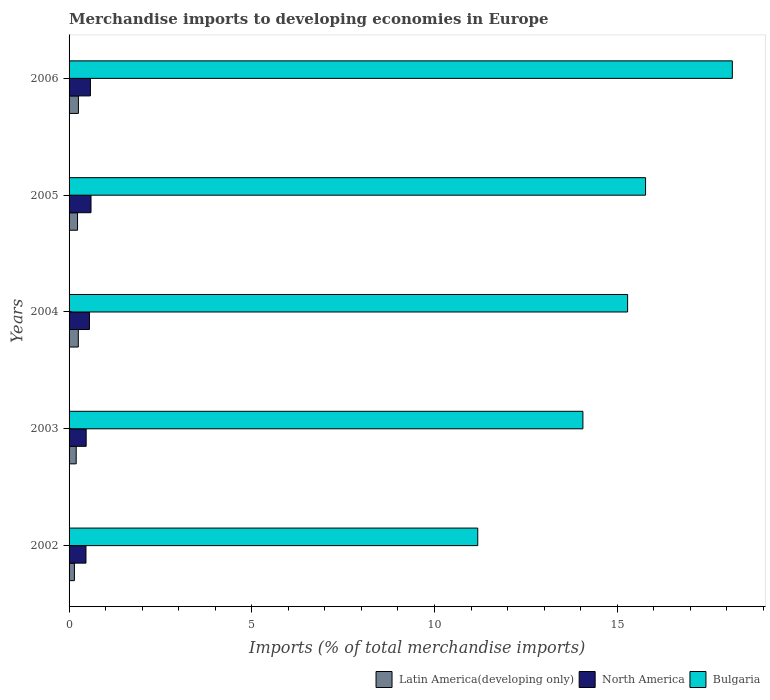How many different coloured bars are there?
Keep it short and to the point. 3. Are the number of bars per tick equal to the number of legend labels?
Give a very brief answer. Yes. Are the number of bars on each tick of the Y-axis equal?
Your answer should be compact. Yes. How many bars are there on the 2nd tick from the bottom?
Give a very brief answer. 3. What is the label of the 1st group of bars from the top?
Your response must be concise. 2006. In how many cases, is the number of bars for a given year not equal to the number of legend labels?
Keep it short and to the point. 0. What is the percentage total merchandise imports in North America in 2004?
Make the answer very short. 0.56. Across all years, what is the maximum percentage total merchandise imports in Latin America(developing only)?
Offer a very short reply. 0.26. Across all years, what is the minimum percentage total merchandise imports in North America?
Offer a terse response. 0.46. In which year was the percentage total merchandise imports in Bulgaria minimum?
Provide a succinct answer. 2002. What is the total percentage total merchandise imports in Latin America(developing only) in the graph?
Keep it short and to the point. 1.08. What is the difference between the percentage total merchandise imports in Latin America(developing only) in 2003 and that in 2006?
Offer a very short reply. -0.06. What is the difference between the percentage total merchandise imports in Bulgaria in 2005 and the percentage total merchandise imports in North America in 2003?
Make the answer very short. 15.31. What is the average percentage total merchandise imports in North America per year?
Offer a very short reply. 0.53. In the year 2003, what is the difference between the percentage total merchandise imports in Bulgaria and percentage total merchandise imports in Latin America(developing only)?
Ensure brevity in your answer.  13.87. In how many years, is the percentage total merchandise imports in North America greater than 10 %?
Your response must be concise. 0. What is the ratio of the percentage total merchandise imports in Bulgaria in 2005 to that in 2006?
Your answer should be compact. 0.87. What is the difference between the highest and the second highest percentage total merchandise imports in North America?
Provide a short and direct response. 0.02. What is the difference between the highest and the lowest percentage total merchandise imports in Bulgaria?
Make the answer very short. 6.97. How many bars are there?
Offer a very short reply. 15. Are all the bars in the graph horizontal?
Make the answer very short. Yes. Does the graph contain grids?
Offer a very short reply. No. Where does the legend appear in the graph?
Make the answer very short. Bottom right. What is the title of the graph?
Keep it short and to the point. Merchandise imports to developing economies in Europe. Does "North America" appear as one of the legend labels in the graph?
Offer a very short reply. Yes. What is the label or title of the X-axis?
Your answer should be very brief. Imports (% of total merchandise imports). What is the label or title of the Y-axis?
Make the answer very short. Years. What is the Imports (% of total merchandise imports) in Latin America(developing only) in 2002?
Ensure brevity in your answer.  0.15. What is the Imports (% of total merchandise imports) of North America in 2002?
Give a very brief answer. 0.46. What is the Imports (% of total merchandise imports) of Bulgaria in 2002?
Your response must be concise. 11.18. What is the Imports (% of total merchandise imports) in Latin America(developing only) in 2003?
Make the answer very short. 0.2. What is the Imports (% of total merchandise imports) of North America in 2003?
Your answer should be compact. 0.47. What is the Imports (% of total merchandise imports) in Bulgaria in 2003?
Your answer should be compact. 14.06. What is the Imports (% of total merchandise imports) in Latin America(developing only) in 2004?
Offer a very short reply. 0.25. What is the Imports (% of total merchandise imports) in North America in 2004?
Keep it short and to the point. 0.56. What is the Imports (% of total merchandise imports) in Bulgaria in 2004?
Provide a short and direct response. 15.29. What is the Imports (% of total merchandise imports) in Latin America(developing only) in 2005?
Give a very brief answer. 0.23. What is the Imports (% of total merchandise imports) of North America in 2005?
Provide a succinct answer. 0.6. What is the Imports (% of total merchandise imports) of Bulgaria in 2005?
Keep it short and to the point. 15.78. What is the Imports (% of total merchandise imports) of Latin America(developing only) in 2006?
Offer a very short reply. 0.26. What is the Imports (% of total merchandise imports) in North America in 2006?
Provide a succinct answer. 0.58. What is the Imports (% of total merchandise imports) of Bulgaria in 2006?
Ensure brevity in your answer.  18.15. Across all years, what is the maximum Imports (% of total merchandise imports) of Latin America(developing only)?
Offer a terse response. 0.26. Across all years, what is the maximum Imports (% of total merchandise imports) of North America?
Your answer should be compact. 0.6. Across all years, what is the maximum Imports (% of total merchandise imports) of Bulgaria?
Ensure brevity in your answer.  18.15. Across all years, what is the minimum Imports (% of total merchandise imports) in Latin America(developing only)?
Your answer should be compact. 0.15. Across all years, what is the minimum Imports (% of total merchandise imports) of North America?
Your answer should be compact. 0.46. Across all years, what is the minimum Imports (% of total merchandise imports) in Bulgaria?
Make the answer very short. 11.18. What is the total Imports (% of total merchandise imports) in Latin America(developing only) in the graph?
Offer a very short reply. 1.08. What is the total Imports (% of total merchandise imports) in North America in the graph?
Make the answer very short. 2.67. What is the total Imports (% of total merchandise imports) of Bulgaria in the graph?
Offer a very short reply. 74.46. What is the difference between the Imports (% of total merchandise imports) in Latin America(developing only) in 2002 and that in 2003?
Give a very brief answer. -0.05. What is the difference between the Imports (% of total merchandise imports) in North America in 2002 and that in 2003?
Your answer should be compact. -0.01. What is the difference between the Imports (% of total merchandise imports) of Bulgaria in 2002 and that in 2003?
Provide a succinct answer. -2.88. What is the difference between the Imports (% of total merchandise imports) of Latin America(developing only) in 2002 and that in 2004?
Your answer should be compact. -0.11. What is the difference between the Imports (% of total merchandise imports) in North America in 2002 and that in 2004?
Your answer should be compact. -0.1. What is the difference between the Imports (% of total merchandise imports) of Bulgaria in 2002 and that in 2004?
Your response must be concise. -4.1. What is the difference between the Imports (% of total merchandise imports) of Latin America(developing only) in 2002 and that in 2005?
Provide a succinct answer. -0.09. What is the difference between the Imports (% of total merchandise imports) in North America in 2002 and that in 2005?
Offer a very short reply. -0.14. What is the difference between the Imports (% of total merchandise imports) of Bulgaria in 2002 and that in 2005?
Your answer should be very brief. -4.59. What is the difference between the Imports (% of total merchandise imports) of Latin America(developing only) in 2002 and that in 2006?
Keep it short and to the point. -0.11. What is the difference between the Imports (% of total merchandise imports) in North America in 2002 and that in 2006?
Give a very brief answer. -0.12. What is the difference between the Imports (% of total merchandise imports) of Bulgaria in 2002 and that in 2006?
Your answer should be very brief. -6.97. What is the difference between the Imports (% of total merchandise imports) in Latin America(developing only) in 2003 and that in 2004?
Offer a terse response. -0.06. What is the difference between the Imports (% of total merchandise imports) in North America in 2003 and that in 2004?
Your answer should be very brief. -0.09. What is the difference between the Imports (% of total merchandise imports) in Bulgaria in 2003 and that in 2004?
Make the answer very short. -1.22. What is the difference between the Imports (% of total merchandise imports) in Latin America(developing only) in 2003 and that in 2005?
Offer a terse response. -0.04. What is the difference between the Imports (% of total merchandise imports) of North America in 2003 and that in 2005?
Keep it short and to the point. -0.13. What is the difference between the Imports (% of total merchandise imports) of Bulgaria in 2003 and that in 2005?
Give a very brief answer. -1.71. What is the difference between the Imports (% of total merchandise imports) in Latin America(developing only) in 2003 and that in 2006?
Your answer should be very brief. -0.06. What is the difference between the Imports (% of total merchandise imports) of North America in 2003 and that in 2006?
Your answer should be very brief. -0.12. What is the difference between the Imports (% of total merchandise imports) in Bulgaria in 2003 and that in 2006?
Provide a short and direct response. -4.09. What is the difference between the Imports (% of total merchandise imports) of Latin America(developing only) in 2004 and that in 2005?
Ensure brevity in your answer.  0.02. What is the difference between the Imports (% of total merchandise imports) in North America in 2004 and that in 2005?
Provide a short and direct response. -0.04. What is the difference between the Imports (% of total merchandise imports) of Bulgaria in 2004 and that in 2005?
Your answer should be compact. -0.49. What is the difference between the Imports (% of total merchandise imports) in Latin America(developing only) in 2004 and that in 2006?
Your answer should be compact. -0. What is the difference between the Imports (% of total merchandise imports) in North America in 2004 and that in 2006?
Provide a succinct answer. -0.03. What is the difference between the Imports (% of total merchandise imports) of Bulgaria in 2004 and that in 2006?
Give a very brief answer. -2.87. What is the difference between the Imports (% of total merchandise imports) in Latin America(developing only) in 2005 and that in 2006?
Your answer should be very brief. -0.02. What is the difference between the Imports (% of total merchandise imports) of North America in 2005 and that in 2006?
Provide a short and direct response. 0.02. What is the difference between the Imports (% of total merchandise imports) in Bulgaria in 2005 and that in 2006?
Your answer should be compact. -2.37. What is the difference between the Imports (% of total merchandise imports) in Latin America(developing only) in 2002 and the Imports (% of total merchandise imports) in North America in 2003?
Provide a succinct answer. -0.32. What is the difference between the Imports (% of total merchandise imports) of Latin America(developing only) in 2002 and the Imports (% of total merchandise imports) of Bulgaria in 2003?
Make the answer very short. -13.92. What is the difference between the Imports (% of total merchandise imports) of Latin America(developing only) in 2002 and the Imports (% of total merchandise imports) of North America in 2004?
Provide a succinct answer. -0.41. What is the difference between the Imports (% of total merchandise imports) in Latin America(developing only) in 2002 and the Imports (% of total merchandise imports) in Bulgaria in 2004?
Offer a terse response. -15.14. What is the difference between the Imports (% of total merchandise imports) of North America in 2002 and the Imports (% of total merchandise imports) of Bulgaria in 2004?
Give a very brief answer. -14.82. What is the difference between the Imports (% of total merchandise imports) of Latin America(developing only) in 2002 and the Imports (% of total merchandise imports) of North America in 2005?
Give a very brief answer. -0.45. What is the difference between the Imports (% of total merchandise imports) of Latin America(developing only) in 2002 and the Imports (% of total merchandise imports) of Bulgaria in 2005?
Ensure brevity in your answer.  -15.63. What is the difference between the Imports (% of total merchandise imports) in North America in 2002 and the Imports (% of total merchandise imports) in Bulgaria in 2005?
Provide a short and direct response. -15.31. What is the difference between the Imports (% of total merchandise imports) of Latin America(developing only) in 2002 and the Imports (% of total merchandise imports) of North America in 2006?
Offer a very short reply. -0.44. What is the difference between the Imports (% of total merchandise imports) in Latin America(developing only) in 2002 and the Imports (% of total merchandise imports) in Bulgaria in 2006?
Keep it short and to the point. -18.01. What is the difference between the Imports (% of total merchandise imports) in North America in 2002 and the Imports (% of total merchandise imports) in Bulgaria in 2006?
Provide a short and direct response. -17.69. What is the difference between the Imports (% of total merchandise imports) in Latin America(developing only) in 2003 and the Imports (% of total merchandise imports) in North America in 2004?
Offer a terse response. -0.36. What is the difference between the Imports (% of total merchandise imports) of Latin America(developing only) in 2003 and the Imports (% of total merchandise imports) of Bulgaria in 2004?
Provide a short and direct response. -15.09. What is the difference between the Imports (% of total merchandise imports) of North America in 2003 and the Imports (% of total merchandise imports) of Bulgaria in 2004?
Offer a terse response. -14.82. What is the difference between the Imports (% of total merchandise imports) of Latin America(developing only) in 2003 and the Imports (% of total merchandise imports) of North America in 2005?
Offer a terse response. -0.41. What is the difference between the Imports (% of total merchandise imports) in Latin America(developing only) in 2003 and the Imports (% of total merchandise imports) in Bulgaria in 2005?
Provide a succinct answer. -15.58. What is the difference between the Imports (% of total merchandise imports) in North America in 2003 and the Imports (% of total merchandise imports) in Bulgaria in 2005?
Your answer should be very brief. -15.31. What is the difference between the Imports (% of total merchandise imports) in Latin America(developing only) in 2003 and the Imports (% of total merchandise imports) in North America in 2006?
Offer a terse response. -0.39. What is the difference between the Imports (% of total merchandise imports) in Latin America(developing only) in 2003 and the Imports (% of total merchandise imports) in Bulgaria in 2006?
Give a very brief answer. -17.96. What is the difference between the Imports (% of total merchandise imports) in North America in 2003 and the Imports (% of total merchandise imports) in Bulgaria in 2006?
Your response must be concise. -17.68. What is the difference between the Imports (% of total merchandise imports) of Latin America(developing only) in 2004 and the Imports (% of total merchandise imports) of North America in 2005?
Your response must be concise. -0.35. What is the difference between the Imports (% of total merchandise imports) of Latin America(developing only) in 2004 and the Imports (% of total merchandise imports) of Bulgaria in 2005?
Keep it short and to the point. -15.52. What is the difference between the Imports (% of total merchandise imports) of North America in 2004 and the Imports (% of total merchandise imports) of Bulgaria in 2005?
Keep it short and to the point. -15.22. What is the difference between the Imports (% of total merchandise imports) in Latin America(developing only) in 2004 and the Imports (% of total merchandise imports) in North America in 2006?
Make the answer very short. -0.33. What is the difference between the Imports (% of total merchandise imports) of Latin America(developing only) in 2004 and the Imports (% of total merchandise imports) of Bulgaria in 2006?
Offer a terse response. -17.9. What is the difference between the Imports (% of total merchandise imports) in North America in 2004 and the Imports (% of total merchandise imports) in Bulgaria in 2006?
Provide a succinct answer. -17.59. What is the difference between the Imports (% of total merchandise imports) of Latin America(developing only) in 2005 and the Imports (% of total merchandise imports) of North America in 2006?
Your answer should be very brief. -0.35. What is the difference between the Imports (% of total merchandise imports) of Latin America(developing only) in 2005 and the Imports (% of total merchandise imports) of Bulgaria in 2006?
Make the answer very short. -17.92. What is the difference between the Imports (% of total merchandise imports) in North America in 2005 and the Imports (% of total merchandise imports) in Bulgaria in 2006?
Provide a short and direct response. -17.55. What is the average Imports (% of total merchandise imports) in Latin America(developing only) per year?
Provide a short and direct response. 0.22. What is the average Imports (% of total merchandise imports) in North America per year?
Offer a very short reply. 0.53. What is the average Imports (% of total merchandise imports) of Bulgaria per year?
Give a very brief answer. 14.89. In the year 2002, what is the difference between the Imports (% of total merchandise imports) in Latin America(developing only) and Imports (% of total merchandise imports) in North America?
Offer a terse response. -0.32. In the year 2002, what is the difference between the Imports (% of total merchandise imports) in Latin America(developing only) and Imports (% of total merchandise imports) in Bulgaria?
Make the answer very short. -11.04. In the year 2002, what is the difference between the Imports (% of total merchandise imports) in North America and Imports (% of total merchandise imports) in Bulgaria?
Give a very brief answer. -10.72. In the year 2003, what is the difference between the Imports (% of total merchandise imports) in Latin America(developing only) and Imports (% of total merchandise imports) in North America?
Provide a succinct answer. -0.27. In the year 2003, what is the difference between the Imports (% of total merchandise imports) in Latin America(developing only) and Imports (% of total merchandise imports) in Bulgaria?
Make the answer very short. -13.87. In the year 2003, what is the difference between the Imports (% of total merchandise imports) of North America and Imports (% of total merchandise imports) of Bulgaria?
Provide a succinct answer. -13.59. In the year 2004, what is the difference between the Imports (% of total merchandise imports) in Latin America(developing only) and Imports (% of total merchandise imports) in North America?
Ensure brevity in your answer.  -0.3. In the year 2004, what is the difference between the Imports (% of total merchandise imports) of Latin America(developing only) and Imports (% of total merchandise imports) of Bulgaria?
Make the answer very short. -15.03. In the year 2004, what is the difference between the Imports (% of total merchandise imports) in North America and Imports (% of total merchandise imports) in Bulgaria?
Your answer should be very brief. -14.73. In the year 2005, what is the difference between the Imports (% of total merchandise imports) of Latin America(developing only) and Imports (% of total merchandise imports) of North America?
Your answer should be very brief. -0.37. In the year 2005, what is the difference between the Imports (% of total merchandise imports) in Latin America(developing only) and Imports (% of total merchandise imports) in Bulgaria?
Your answer should be very brief. -15.55. In the year 2005, what is the difference between the Imports (% of total merchandise imports) in North America and Imports (% of total merchandise imports) in Bulgaria?
Keep it short and to the point. -15.18. In the year 2006, what is the difference between the Imports (% of total merchandise imports) in Latin America(developing only) and Imports (% of total merchandise imports) in North America?
Ensure brevity in your answer.  -0.33. In the year 2006, what is the difference between the Imports (% of total merchandise imports) in Latin America(developing only) and Imports (% of total merchandise imports) in Bulgaria?
Keep it short and to the point. -17.9. In the year 2006, what is the difference between the Imports (% of total merchandise imports) of North America and Imports (% of total merchandise imports) of Bulgaria?
Provide a succinct answer. -17.57. What is the ratio of the Imports (% of total merchandise imports) of Latin America(developing only) in 2002 to that in 2003?
Offer a terse response. 0.75. What is the ratio of the Imports (% of total merchandise imports) in North America in 2002 to that in 2003?
Offer a terse response. 0.99. What is the ratio of the Imports (% of total merchandise imports) in Bulgaria in 2002 to that in 2003?
Offer a terse response. 0.8. What is the ratio of the Imports (% of total merchandise imports) in Latin America(developing only) in 2002 to that in 2004?
Keep it short and to the point. 0.58. What is the ratio of the Imports (% of total merchandise imports) of North America in 2002 to that in 2004?
Your response must be concise. 0.83. What is the ratio of the Imports (% of total merchandise imports) of Bulgaria in 2002 to that in 2004?
Your response must be concise. 0.73. What is the ratio of the Imports (% of total merchandise imports) of Latin America(developing only) in 2002 to that in 2005?
Your answer should be very brief. 0.63. What is the ratio of the Imports (% of total merchandise imports) of North America in 2002 to that in 2005?
Make the answer very short. 0.77. What is the ratio of the Imports (% of total merchandise imports) of Bulgaria in 2002 to that in 2005?
Your response must be concise. 0.71. What is the ratio of the Imports (% of total merchandise imports) in Latin America(developing only) in 2002 to that in 2006?
Give a very brief answer. 0.57. What is the ratio of the Imports (% of total merchandise imports) of North America in 2002 to that in 2006?
Provide a short and direct response. 0.79. What is the ratio of the Imports (% of total merchandise imports) in Bulgaria in 2002 to that in 2006?
Offer a terse response. 0.62. What is the ratio of the Imports (% of total merchandise imports) of Latin America(developing only) in 2003 to that in 2004?
Your answer should be very brief. 0.77. What is the ratio of the Imports (% of total merchandise imports) in North America in 2003 to that in 2004?
Provide a succinct answer. 0.84. What is the ratio of the Imports (% of total merchandise imports) of Bulgaria in 2003 to that in 2004?
Your response must be concise. 0.92. What is the ratio of the Imports (% of total merchandise imports) of Latin America(developing only) in 2003 to that in 2005?
Your response must be concise. 0.84. What is the ratio of the Imports (% of total merchandise imports) in North America in 2003 to that in 2005?
Ensure brevity in your answer.  0.78. What is the ratio of the Imports (% of total merchandise imports) of Bulgaria in 2003 to that in 2005?
Make the answer very short. 0.89. What is the ratio of the Imports (% of total merchandise imports) in Latin America(developing only) in 2003 to that in 2006?
Your answer should be very brief. 0.77. What is the ratio of the Imports (% of total merchandise imports) in North America in 2003 to that in 2006?
Provide a short and direct response. 0.8. What is the ratio of the Imports (% of total merchandise imports) in Bulgaria in 2003 to that in 2006?
Your answer should be very brief. 0.77. What is the ratio of the Imports (% of total merchandise imports) of Latin America(developing only) in 2004 to that in 2005?
Give a very brief answer. 1.09. What is the ratio of the Imports (% of total merchandise imports) in North America in 2004 to that in 2005?
Keep it short and to the point. 0.93. What is the ratio of the Imports (% of total merchandise imports) of Bulgaria in 2004 to that in 2005?
Keep it short and to the point. 0.97. What is the ratio of the Imports (% of total merchandise imports) in North America in 2004 to that in 2006?
Ensure brevity in your answer.  0.95. What is the ratio of the Imports (% of total merchandise imports) in Bulgaria in 2004 to that in 2006?
Provide a short and direct response. 0.84. What is the ratio of the Imports (% of total merchandise imports) in Latin America(developing only) in 2005 to that in 2006?
Offer a very short reply. 0.91. What is the ratio of the Imports (% of total merchandise imports) in North America in 2005 to that in 2006?
Ensure brevity in your answer.  1.03. What is the ratio of the Imports (% of total merchandise imports) in Bulgaria in 2005 to that in 2006?
Your answer should be very brief. 0.87. What is the difference between the highest and the second highest Imports (% of total merchandise imports) of Latin America(developing only)?
Provide a succinct answer. 0. What is the difference between the highest and the second highest Imports (% of total merchandise imports) of North America?
Ensure brevity in your answer.  0.02. What is the difference between the highest and the second highest Imports (% of total merchandise imports) of Bulgaria?
Provide a succinct answer. 2.37. What is the difference between the highest and the lowest Imports (% of total merchandise imports) in Latin America(developing only)?
Provide a succinct answer. 0.11. What is the difference between the highest and the lowest Imports (% of total merchandise imports) in North America?
Your answer should be compact. 0.14. What is the difference between the highest and the lowest Imports (% of total merchandise imports) of Bulgaria?
Offer a terse response. 6.97. 